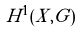Convert formula to latex. <formula><loc_0><loc_0><loc_500><loc_500>H ^ { 1 } ( X , G )</formula> 